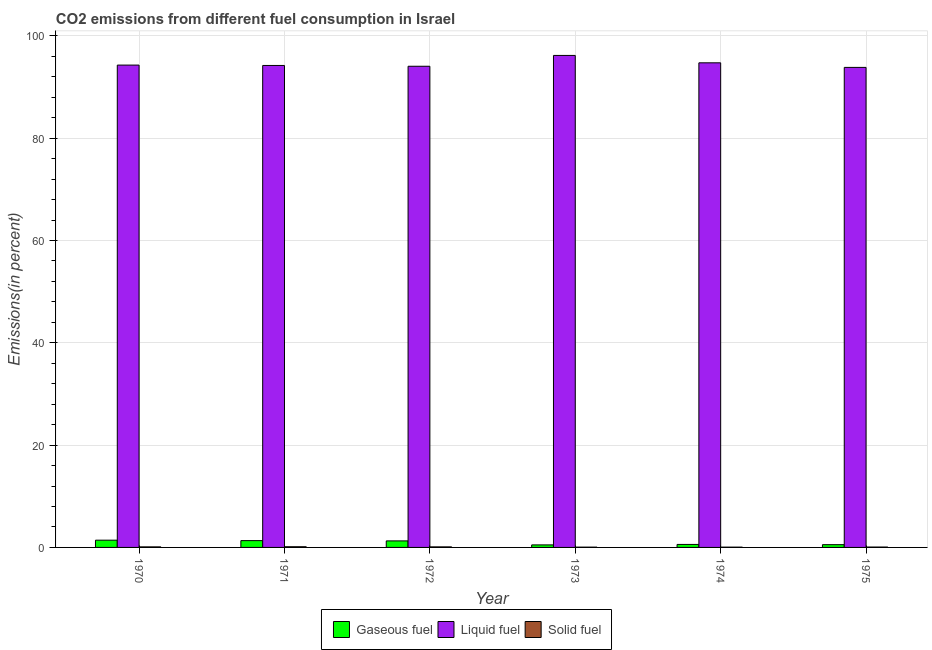Are the number of bars per tick equal to the number of legend labels?
Offer a very short reply. Yes. How many bars are there on the 5th tick from the left?
Provide a succinct answer. 3. What is the label of the 3rd group of bars from the left?
Make the answer very short. 1972. In how many cases, is the number of bars for a given year not equal to the number of legend labels?
Make the answer very short. 0. What is the percentage of solid fuel emission in 1970?
Make the answer very short. 0.11. Across all years, what is the maximum percentage of gaseous fuel emission?
Give a very brief answer. 1.42. Across all years, what is the minimum percentage of gaseous fuel emission?
Your response must be concise. 0.49. In which year was the percentage of solid fuel emission minimum?
Your answer should be very brief. 1974. What is the total percentage of gaseous fuel emission in the graph?
Offer a terse response. 5.64. What is the difference between the percentage of liquid fuel emission in 1972 and that in 1973?
Ensure brevity in your answer.  -2.12. What is the difference between the percentage of liquid fuel emission in 1970 and the percentage of solid fuel emission in 1972?
Give a very brief answer. 0.23. What is the average percentage of liquid fuel emission per year?
Ensure brevity in your answer.  94.56. In how many years, is the percentage of liquid fuel emission greater than 12 %?
Offer a terse response. 6. What is the ratio of the percentage of solid fuel emission in 1972 to that in 1973?
Ensure brevity in your answer.  1.9. What is the difference between the highest and the second highest percentage of gaseous fuel emission?
Offer a very short reply. 0.08. What is the difference between the highest and the lowest percentage of gaseous fuel emission?
Offer a terse response. 0.92. In how many years, is the percentage of solid fuel emission greater than the average percentage of solid fuel emission taken over all years?
Provide a short and direct response. 3. Is the sum of the percentage of gaseous fuel emission in 1973 and 1974 greater than the maximum percentage of solid fuel emission across all years?
Provide a short and direct response. No. What does the 3rd bar from the left in 1973 represents?
Offer a terse response. Solid fuel. What does the 3rd bar from the right in 1974 represents?
Your answer should be very brief. Gaseous fuel. Is it the case that in every year, the sum of the percentage of gaseous fuel emission and percentage of liquid fuel emission is greater than the percentage of solid fuel emission?
Your answer should be compact. Yes. Are all the bars in the graph horizontal?
Offer a terse response. No. Are the values on the major ticks of Y-axis written in scientific E-notation?
Your response must be concise. No. Does the graph contain any zero values?
Give a very brief answer. No. Does the graph contain grids?
Make the answer very short. Yes. Where does the legend appear in the graph?
Your answer should be very brief. Bottom center. How are the legend labels stacked?
Offer a very short reply. Horizontal. What is the title of the graph?
Keep it short and to the point. CO2 emissions from different fuel consumption in Israel. What is the label or title of the X-axis?
Make the answer very short. Year. What is the label or title of the Y-axis?
Provide a succinct answer. Emissions(in percent). What is the Emissions(in percent) of Gaseous fuel in 1970?
Offer a very short reply. 1.42. What is the Emissions(in percent) in Liquid fuel in 1970?
Offer a terse response. 94.29. What is the Emissions(in percent) in Solid fuel in 1970?
Your response must be concise. 0.11. What is the Emissions(in percent) of Gaseous fuel in 1971?
Make the answer very short. 1.33. What is the Emissions(in percent) in Liquid fuel in 1971?
Keep it short and to the point. 94.22. What is the Emissions(in percent) of Solid fuel in 1971?
Ensure brevity in your answer.  0.14. What is the Emissions(in percent) in Gaseous fuel in 1972?
Give a very brief answer. 1.28. What is the Emissions(in percent) in Liquid fuel in 1972?
Offer a very short reply. 94.07. What is the Emissions(in percent) of Solid fuel in 1972?
Offer a very short reply. 0.11. What is the Emissions(in percent) in Gaseous fuel in 1973?
Your response must be concise. 0.49. What is the Emissions(in percent) in Liquid fuel in 1973?
Keep it short and to the point. 96.18. What is the Emissions(in percent) of Solid fuel in 1973?
Your answer should be very brief. 0.06. What is the Emissions(in percent) of Gaseous fuel in 1974?
Your response must be concise. 0.58. What is the Emissions(in percent) of Liquid fuel in 1974?
Ensure brevity in your answer.  94.74. What is the Emissions(in percent) of Solid fuel in 1974?
Provide a succinct answer. 0.06. What is the Emissions(in percent) in Gaseous fuel in 1975?
Provide a short and direct response. 0.54. What is the Emissions(in percent) in Liquid fuel in 1975?
Provide a short and direct response. 93.84. What is the Emissions(in percent) in Solid fuel in 1975?
Offer a very short reply. 0.07. Across all years, what is the maximum Emissions(in percent) of Gaseous fuel?
Your answer should be very brief. 1.42. Across all years, what is the maximum Emissions(in percent) of Liquid fuel?
Offer a terse response. 96.18. Across all years, what is the maximum Emissions(in percent) of Solid fuel?
Your answer should be compact. 0.14. Across all years, what is the minimum Emissions(in percent) in Gaseous fuel?
Provide a succinct answer. 0.49. Across all years, what is the minimum Emissions(in percent) in Liquid fuel?
Provide a succinct answer. 93.84. Across all years, what is the minimum Emissions(in percent) in Solid fuel?
Provide a short and direct response. 0.06. What is the total Emissions(in percent) in Gaseous fuel in the graph?
Offer a very short reply. 5.64. What is the total Emissions(in percent) in Liquid fuel in the graph?
Offer a very short reply. 567.35. What is the total Emissions(in percent) in Solid fuel in the graph?
Provide a succinct answer. 0.54. What is the difference between the Emissions(in percent) in Gaseous fuel in 1970 and that in 1971?
Your answer should be compact. 0.08. What is the difference between the Emissions(in percent) of Liquid fuel in 1970 and that in 1971?
Ensure brevity in your answer.  0.07. What is the difference between the Emissions(in percent) of Solid fuel in 1970 and that in 1971?
Your response must be concise. -0.02. What is the difference between the Emissions(in percent) in Gaseous fuel in 1970 and that in 1972?
Your answer should be compact. 0.14. What is the difference between the Emissions(in percent) of Liquid fuel in 1970 and that in 1972?
Give a very brief answer. 0.23. What is the difference between the Emissions(in percent) in Solid fuel in 1970 and that in 1972?
Your answer should be very brief. 0. What is the difference between the Emissions(in percent) of Gaseous fuel in 1970 and that in 1973?
Keep it short and to the point. 0.92. What is the difference between the Emissions(in percent) in Liquid fuel in 1970 and that in 1973?
Provide a succinct answer. -1.89. What is the difference between the Emissions(in percent) in Solid fuel in 1970 and that in 1973?
Ensure brevity in your answer.  0.05. What is the difference between the Emissions(in percent) of Gaseous fuel in 1970 and that in 1974?
Give a very brief answer. 0.83. What is the difference between the Emissions(in percent) of Liquid fuel in 1970 and that in 1974?
Ensure brevity in your answer.  -0.45. What is the difference between the Emissions(in percent) in Solid fuel in 1970 and that in 1974?
Offer a very short reply. 0.05. What is the difference between the Emissions(in percent) of Gaseous fuel in 1970 and that in 1975?
Keep it short and to the point. 0.87. What is the difference between the Emissions(in percent) in Liquid fuel in 1970 and that in 1975?
Make the answer very short. 0.45. What is the difference between the Emissions(in percent) of Solid fuel in 1970 and that in 1975?
Give a very brief answer. 0.04. What is the difference between the Emissions(in percent) in Gaseous fuel in 1971 and that in 1972?
Your answer should be compact. 0.05. What is the difference between the Emissions(in percent) of Liquid fuel in 1971 and that in 1972?
Provide a short and direct response. 0.16. What is the difference between the Emissions(in percent) in Solid fuel in 1971 and that in 1972?
Offer a very short reply. 0.03. What is the difference between the Emissions(in percent) in Gaseous fuel in 1971 and that in 1973?
Your answer should be compact. 0.84. What is the difference between the Emissions(in percent) of Liquid fuel in 1971 and that in 1973?
Provide a succinct answer. -1.96. What is the difference between the Emissions(in percent) of Solid fuel in 1971 and that in 1973?
Your answer should be compact. 0.08. What is the difference between the Emissions(in percent) of Gaseous fuel in 1971 and that in 1974?
Make the answer very short. 0.75. What is the difference between the Emissions(in percent) in Liquid fuel in 1971 and that in 1974?
Offer a very short reply. -0.52. What is the difference between the Emissions(in percent) of Solid fuel in 1971 and that in 1974?
Your answer should be very brief. 0.08. What is the difference between the Emissions(in percent) of Gaseous fuel in 1971 and that in 1975?
Provide a succinct answer. 0.79. What is the difference between the Emissions(in percent) in Liquid fuel in 1971 and that in 1975?
Provide a short and direct response. 0.38. What is the difference between the Emissions(in percent) in Solid fuel in 1971 and that in 1975?
Keep it short and to the point. 0.06. What is the difference between the Emissions(in percent) in Gaseous fuel in 1972 and that in 1973?
Your answer should be very brief. 0.78. What is the difference between the Emissions(in percent) of Liquid fuel in 1972 and that in 1973?
Offer a terse response. -2.12. What is the difference between the Emissions(in percent) of Solid fuel in 1972 and that in 1973?
Your answer should be compact. 0.05. What is the difference between the Emissions(in percent) in Gaseous fuel in 1972 and that in 1974?
Your answer should be compact. 0.69. What is the difference between the Emissions(in percent) in Liquid fuel in 1972 and that in 1974?
Give a very brief answer. -0.67. What is the difference between the Emissions(in percent) of Solid fuel in 1972 and that in 1974?
Ensure brevity in your answer.  0.05. What is the difference between the Emissions(in percent) of Gaseous fuel in 1972 and that in 1975?
Offer a very short reply. 0.74. What is the difference between the Emissions(in percent) in Liquid fuel in 1972 and that in 1975?
Your answer should be compact. 0.23. What is the difference between the Emissions(in percent) in Solid fuel in 1972 and that in 1975?
Your answer should be compact. 0.03. What is the difference between the Emissions(in percent) in Gaseous fuel in 1973 and that in 1974?
Your response must be concise. -0.09. What is the difference between the Emissions(in percent) in Liquid fuel in 1973 and that in 1974?
Provide a succinct answer. 1.44. What is the difference between the Emissions(in percent) of Gaseous fuel in 1973 and that in 1975?
Provide a succinct answer. -0.05. What is the difference between the Emissions(in percent) of Liquid fuel in 1973 and that in 1975?
Offer a very short reply. 2.34. What is the difference between the Emissions(in percent) of Solid fuel in 1973 and that in 1975?
Offer a very short reply. -0.02. What is the difference between the Emissions(in percent) of Gaseous fuel in 1974 and that in 1975?
Offer a very short reply. 0.04. What is the difference between the Emissions(in percent) in Liquid fuel in 1974 and that in 1975?
Offer a very short reply. 0.9. What is the difference between the Emissions(in percent) of Solid fuel in 1974 and that in 1975?
Your answer should be very brief. -0.02. What is the difference between the Emissions(in percent) of Gaseous fuel in 1970 and the Emissions(in percent) of Liquid fuel in 1971?
Make the answer very short. -92.81. What is the difference between the Emissions(in percent) in Gaseous fuel in 1970 and the Emissions(in percent) in Solid fuel in 1971?
Provide a succinct answer. 1.28. What is the difference between the Emissions(in percent) in Liquid fuel in 1970 and the Emissions(in percent) in Solid fuel in 1971?
Your answer should be compact. 94.16. What is the difference between the Emissions(in percent) of Gaseous fuel in 1970 and the Emissions(in percent) of Liquid fuel in 1972?
Offer a terse response. -92.65. What is the difference between the Emissions(in percent) of Gaseous fuel in 1970 and the Emissions(in percent) of Solid fuel in 1972?
Offer a very short reply. 1.31. What is the difference between the Emissions(in percent) in Liquid fuel in 1970 and the Emissions(in percent) in Solid fuel in 1972?
Your response must be concise. 94.19. What is the difference between the Emissions(in percent) of Gaseous fuel in 1970 and the Emissions(in percent) of Liquid fuel in 1973?
Your answer should be very brief. -94.77. What is the difference between the Emissions(in percent) of Gaseous fuel in 1970 and the Emissions(in percent) of Solid fuel in 1973?
Offer a terse response. 1.36. What is the difference between the Emissions(in percent) in Liquid fuel in 1970 and the Emissions(in percent) in Solid fuel in 1973?
Offer a very short reply. 94.24. What is the difference between the Emissions(in percent) of Gaseous fuel in 1970 and the Emissions(in percent) of Liquid fuel in 1974?
Provide a short and direct response. -93.32. What is the difference between the Emissions(in percent) of Gaseous fuel in 1970 and the Emissions(in percent) of Solid fuel in 1974?
Your response must be concise. 1.36. What is the difference between the Emissions(in percent) of Liquid fuel in 1970 and the Emissions(in percent) of Solid fuel in 1974?
Your answer should be compact. 94.24. What is the difference between the Emissions(in percent) in Gaseous fuel in 1970 and the Emissions(in percent) in Liquid fuel in 1975?
Give a very brief answer. -92.43. What is the difference between the Emissions(in percent) in Gaseous fuel in 1970 and the Emissions(in percent) in Solid fuel in 1975?
Offer a very short reply. 1.34. What is the difference between the Emissions(in percent) of Liquid fuel in 1970 and the Emissions(in percent) of Solid fuel in 1975?
Your answer should be compact. 94.22. What is the difference between the Emissions(in percent) in Gaseous fuel in 1971 and the Emissions(in percent) in Liquid fuel in 1972?
Make the answer very short. -92.74. What is the difference between the Emissions(in percent) of Gaseous fuel in 1971 and the Emissions(in percent) of Solid fuel in 1972?
Your answer should be compact. 1.22. What is the difference between the Emissions(in percent) of Liquid fuel in 1971 and the Emissions(in percent) of Solid fuel in 1972?
Ensure brevity in your answer.  94.11. What is the difference between the Emissions(in percent) in Gaseous fuel in 1971 and the Emissions(in percent) in Liquid fuel in 1973?
Provide a short and direct response. -94.85. What is the difference between the Emissions(in percent) in Gaseous fuel in 1971 and the Emissions(in percent) in Solid fuel in 1973?
Make the answer very short. 1.27. What is the difference between the Emissions(in percent) of Liquid fuel in 1971 and the Emissions(in percent) of Solid fuel in 1973?
Provide a succinct answer. 94.17. What is the difference between the Emissions(in percent) in Gaseous fuel in 1971 and the Emissions(in percent) in Liquid fuel in 1974?
Keep it short and to the point. -93.41. What is the difference between the Emissions(in percent) of Gaseous fuel in 1971 and the Emissions(in percent) of Solid fuel in 1974?
Your answer should be compact. 1.27. What is the difference between the Emissions(in percent) of Liquid fuel in 1971 and the Emissions(in percent) of Solid fuel in 1974?
Provide a short and direct response. 94.17. What is the difference between the Emissions(in percent) in Gaseous fuel in 1971 and the Emissions(in percent) in Liquid fuel in 1975?
Offer a very short reply. -92.51. What is the difference between the Emissions(in percent) of Gaseous fuel in 1971 and the Emissions(in percent) of Solid fuel in 1975?
Your answer should be very brief. 1.26. What is the difference between the Emissions(in percent) of Liquid fuel in 1971 and the Emissions(in percent) of Solid fuel in 1975?
Give a very brief answer. 94.15. What is the difference between the Emissions(in percent) in Gaseous fuel in 1972 and the Emissions(in percent) in Liquid fuel in 1973?
Provide a succinct answer. -94.91. What is the difference between the Emissions(in percent) of Gaseous fuel in 1972 and the Emissions(in percent) of Solid fuel in 1973?
Offer a very short reply. 1.22. What is the difference between the Emissions(in percent) in Liquid fuel in 1972 and the Emissions(in percent) in Solid fuel in 1973?
Provide a short and direct response. 94.01. What is the difference between the Emissions(in percent) of Gaseous fuel in 1972 and the Emissions(in percent) of Liquid fuel in 1974?
Keep it short and to the point. -93.46. What is the difference between the Emissions(in percent) in Gaseous fuel in 1972 and the Emissions(in percent) in Solid fuel in 1974?
Make the answer very short. 1.22. What is the difference between the Emissions(in percent) of Liquid fuel in 1972 and the Emissions(in percent) of Solid fuel in 1974?
Make the answer very short. 94.01. What is the difference between the Emissions(in percent) of Gaseous fuel in 1972 and the Emissions(in percent) of Liquid fuel in 1975?
Your answer should be very brief. -92.56. What is the difference between the Emissions(in percent) of Gaseous fuel in 1972 and the Emissions(in percent) of Solid fuel in 1975?
Your response must be concise. 1.2. What is the difference between the Emissions(in percent) in Liquid fuel in 1972 and the Emissions(in percent) in Solid fuel in 1975?
Keep it short and to the point. 93.99. What is the difference between the Emissions(in percent) of Gaseous fuel in 1973 and the Emissions(in percent) of Liquid fuel in 1974?
Make the answer very short. -94.25. What is the difference between the Emissions(in percent) in Gaseous fuel in 1973 and the Emissions(in percent) in Solid fuel in 1974?
Make the answer very short. 0.44. What is the difference between the Emissions(in percent) in Liquid fuel in 1973 and the Emissions(in percent) in Solid fuel in 1974?
Ensure brevity in your answer.  96.13. What is the difference between the Emissions(in percent) in Gaseous fuel in 1973 and the Emissions(in percent) in Liquid fuel in 1975?
Provide a short and direct response. -93.35. What is the difference between the Emissions(in percent) in Gaseous fuel in 1973 and the Emissions(in percent) in Solid fuel in 1975?
Make the answer very short. 0.42. What is the difference between the Emissions(in percent) of Liquid fuel in 1973 and the Emissions(in percent) of Solid fuel in 1975?
Provide a short and direct response. 96.11. What is the difference between the Emissions(in percent) in Gaseous fuel in 1974 and the Emissions(in percent) in Liquid fuel in 1975?
Your answer should be compact. -93.26. What is the difference between the Emissions(in percent) in Gaseous fuel in 1974 and the Emissions(in percent) in Solid fuel in 1975?
Offer a terse response. 0.51. What is the difference between the Emissions(in percent) of Liquid fuel in 1974 and the Emissions(in percent) of Solid fuel in 1975?
Give a very brief answer. 94.66. What is the average Emissions(in percent) of Gaseous fuel per year?
Make the answer very short. 0.94. What is the average Emissions(in percent) of Liquid fuel per year?
Provide a short and direct response. 94.56. What is the average Emissions(in percent) of Solid fuel per year?
Make the answer very short. 0.09. In the year 1970, what is the difference between the Emissions(in percent) in Gaseous fuel and Emissions(in percent) in Liquid fuel?
Make the answer very short. -92.88. In the year 1970, what is the difference between the Emissions(in percent) in Gaseous fuel and Emissions(in percent) in Solid fuel?
Offer a very short reply. 1.3. In the year 1970, what is the difference between the Emissions(in percent) of Liquid fuel and Emissions(in percent) of Solid fuel?
Provide a succinct answer. 94.18. In the year 1971, what is the difference between the Emissions(in percent) in Gaseous fuel and Emissions(in percent) in Liquid fuel?
Give a very brief answer. -92.89. In the year 1971, what is the difference between the Emissions(in percent) in Gaseous fuel and Emissions(in percent) in Solid fuel?
Provide a succinct answer. 1.2. In the year 1971, what is the difference between the Emissions(in percent) of Liquid fuel and Emissions(in percent) of Solid fuel?
Provide a short and direct response. 94.09. In the year 1972, what is the difference between the Emissions(in percent) of Gaseous fuel and Emissions(in percent) of Liquid fuel?
Make the answer very short. -92.79. In the year 1972, what is the difference between the Emissions(in percent) in Gaseous fuel and Emissions(in percent) in Solid fuel?
Give a very brief answer. 1.17. In the year 1972, what is the difference between the Emissions(in percent) in Liquid fuel and Emissions(in percent) in Solid fuel?
Offer a terse response. 93.96. In the year 1973, what is the difference between the Emissions(in percent) of Gaseous fuel and Emissions(in percent) of Liquid fuel?
Provide a succinct answer. -95.69. In the year 1973, what is the difference between the Emissions(in percent) of Gaseous fuel and Emissions(in percent) of Solid fuel?
Your response must be concise. 0.44. In the year 1973, what is the difference between the Emissions(in percent) of Liquid fuel and Emissions(in percent) of Solid fuel?
Keep it short and to the point. 96.13. In the year 1974, what is the difference between the Emissions(in percent) of Gaseous fuel and Emissions(in percent) of Liquid fuel?
Provide a succinct answer. -94.15. In the year 1974, what is the difference between the Emissions(in percent) in Gaseous fuel and Emissions(in percent) in Solid fuel?
Provide a succinct answer. 0.53. In the year 1974, what is the difference between the Emissions(in percent) of Liquid fuel and Emissions(in percent) of Solid fuel?
Provide a succinct answer. 94.68. In the year 1975, what is the difference between the Emissions(in percent) of Gaseous fuel and Emissions(in percent) of Liquid fuel?
Ensure brevity in your answer.  -93.3. In the year 1975, what is the difference between the Emissions(in percent) of Gaseous fuel and Emissions(in percent) of Solid fuel?
Offer a terse response. 0.47. In the year 1975, what is the difference between the Emissions(in percent) in Liquid fuel and Emissions(in percent) in Solid fuel?
Ensure brevity in your answer.  93.77. What is the ratio of the Emissions(in percent) of Gaseous fuel in 1970 to that in 1971?
Your answer should be very brief. 1.06. What is the ratio of the Emissions(in percent) of Solid fuel in 1970 to that in 1971?
Your response must be concise. 0.82. What is the ratio of the Emissions(in percent) in Gaseous fuel in 1970 to that in 1972?
Give a very brief answer. 1.11. What is the ratio of the Emissions(in percent) of Liquid fuel in 1970 to that in 1972?
Keep it short and to the point. 1. What is the ratio of the Emissions(in percent) in Solid fuel in 1970 to that in 1972?
Provide a short and direct response. 1.02. What is the ratio of the Emissions(in percent) of Gaseous fuel in 1970 to that in 1973?
Make the answer very short. 2.87. What is the ratio of the Emissions(in percent) of Liquid fuel in 1970 to that in 1973?
Your answer should be compact. 0.98. What is the ratio of the Emissions(in percent) of Solid fuel in 1970 to that in 1973?
Your answer should be compact. 1.94. What is the ratio of the Emissions(in percent) of Gaseous fuel in 1970 to that in 1974?
Provide a short and direct response. 2.42. What is the ratio of the Emissions(in percent) of Liquid fuel in 1970 to that in 1974?
Offer a terse response. 1. What is the ratio of the Emissions(in percent) in Solid fuel in 1970 to that in 1974?
Your answer should be very brief. 1.96. What is the ratio of the Emissions(in percent) in Gaseous fuel in 1970 to that in 1975?
Provide a short and direct response. 2.62. What is the ratio of the Emissions(in percent) in Solid fuel in 1970 to that in 1975?
Offer a very short reply. 1.48. What is the ratio of the Emissions(in percent) in Gaseous fuel in 1971 to that in 1972?
Give a very brief answer. 1.04. What is the ratio of the Emissions(in percent) of Liquid fuel in 1971 to that in 1972?
Keep it short and to the point. 1. What is the ratio of the Emissions(in percent) of Solid fuel in 1971 to that in 1972?
Provide a succinct answer. 1.25. What is the ratio of the Emissions(in percent) in Gaseous fuel in 1971 to that in 1973?
Provide a succinct answer. 2.7. What is the ratio of the Emissions(in percent) of Liquid fuel in 1971 to that in 1973?
Your response must be concise. 0.98. What is the ratio of the Emissions(in percent) of Solid fuel in 1971 to that in 1973?
Offer a very short reply. 2.38. What is the ratio of the Emissions(in percent) in Gaseous fuel in 1971 to that in 1974?
Ensure brevity in your answer.  2.28. What is the ratio of the Emissions(in percent) in Solid fuel in 1971 to that in 1974?
Give a very brief answer. 2.39. What is the ratio of the Emissions(in percent) of Gaseous fuel in 1971 to that in 1975?
Give a very brief answer. 2.46. What is the ratio of the Emissions(in percent) of Liquid fuel in 1971 to that in 1975?
Provide a succinct answer. 1. What is the ratio of the Emissions(in percent) of Solid fuel in 1971 to that in 1975?
Provide a short and direct response. 1.81. What is the ratio of the Emissions(in percent) in Gaseous fuel in 1972 to that in 1973?
Keep it short and to the point. 2.59. What is the ratio of the Emissions(in percent) of Liquid fuel in 1972 to that in 1973?
Give a very brief answer. 0.98. What is the ratio of the Emissions(in percent) of Solid fuel in 1972 to that in 1973?
Give a very brief answer. 1.9. What is the ratio of the Emissions(in percent) of Gaseous fuel in 1972 to that in 1974?
Offer a very short reply. 2.19. What is the ratio of the Emissions(in percent) of Liquid fuel in 1972 to that in 1974?
Your answer should be compact. 0.99. What is the ratio of the Emissions(in percent) in Solid fuel in 1972 to that in 1974?
Provide a succinct answer. 1.91. What is the ratio of the Emissions(in percent) in Gaseous fuel in 1972 to that in 1975?
Give a very brief answer. 2.36. What is the ratio of the Emissions(in percent) of Solid fuel in 1972 to that in 1975?
Keep it short and to the point. 1.45. What is the ratio of the Emissions(in percent) of Gaseous fuel in 1973 to that in 1974?
Keep it short and to the point. 0.84. What is the ratio of the Emissions(in percent) in Liquid fuel in 1973 to that in 1974?
Your answer should be compact. 1.02. What is the ratio of the Emissions(in percent) in Solid fuel in 1973 to that in 1974?
Make the answer very short. 1.01. What is the ratio of the Emissions(in percent) in Gaseous fuel in 1973 to that in 1975?
Give a very brief answer. 0.91. What is the ratio of the Emissions(in percent) of Solid fuel in 1973 to that in 1975?
Give a very brief answer. 0.76. What is the ratio of the Emissions(in percent) in Gaseous fuel in 1974 to that in 1975?
Your answer should be very brief. 1.08. What is the ratio of the Emissions(in percent) of Liquid fuel in 1974 to that in 1975?
Provide a short and direct response. 1.01. What is the ratio of the Emissions(in percent) of Solid fuel in 1974 to that in 1975?
Provide a short and direct response. 0.76. What is the difference between the highest and the second highest Emissions(in percent) of Gaseous fuel?
Make the answer very short. 0.08. What is the difference between the highest and the second highest Emissions(in percent) of Liquid fuel?
Offer a terse response. 1.44. What is the difference between the highest and the second highest Emissions(in percent) in Solid fuel?
Your response must be concise. 0.02. What is the difference between the highest and the lowest Emissions(in percent) of Gaseous fuel?
Offer a very short reply. 0.92. What is the difference between the highest and the lowest Emissions(in percent) in Liquid fuel?
Provide a short and direct response. 2.34. What is the difference between the highest and the lowest Emissions(in percent) in Solid fuel?
Offer a very short reply. 0.08. 